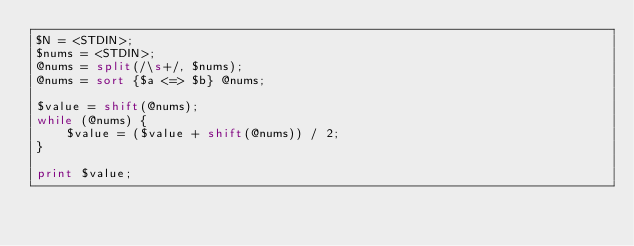Convert code to text. <code><loc_0><loc_0><loc_500><loc_500><_Perl_>$N = <STDIN>;
$nums = <STDIN>;
@nums = split(/\s+/, $nums);
@nums = sort {$a <=> $b} @nums;

$value = shift(@nums);
while (@nums) {
    $value = ($value + shift(@nums)) / 2;
}

print $value;</code> 